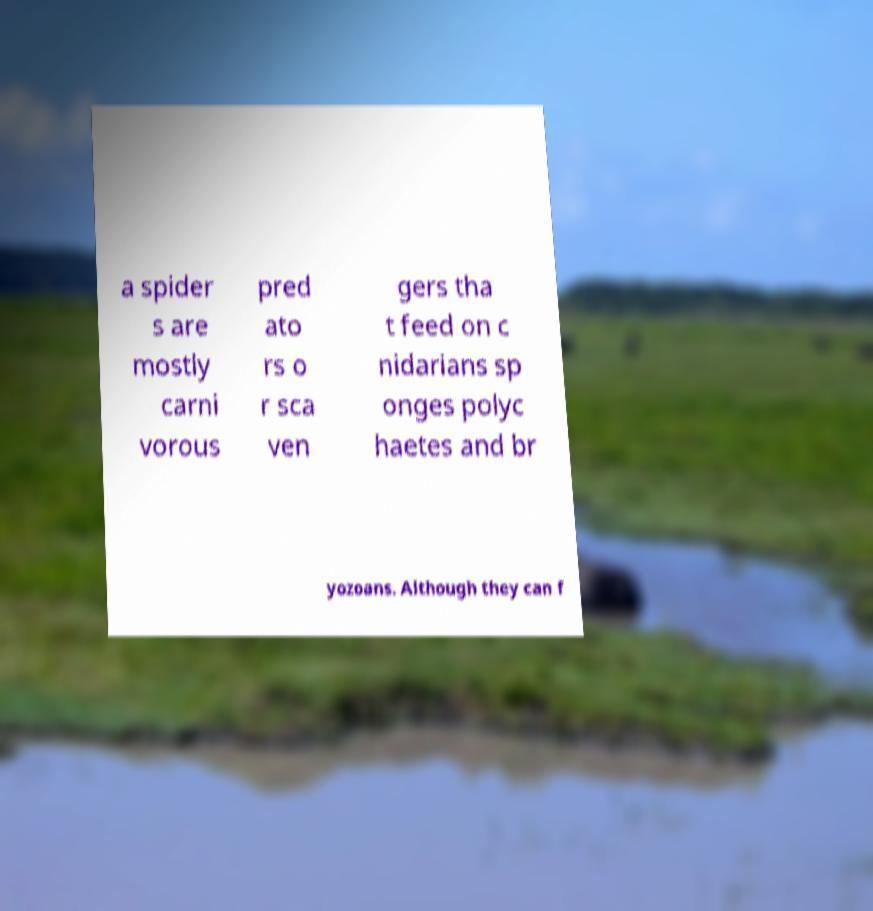I need the written content from this picture converted into text. Can you do that? a spider s are mostly carni vorous pred ato rs o r sca ven gers tha t feed on c nidarians sp onges polyc haetes and br yozoans. Although they can f 